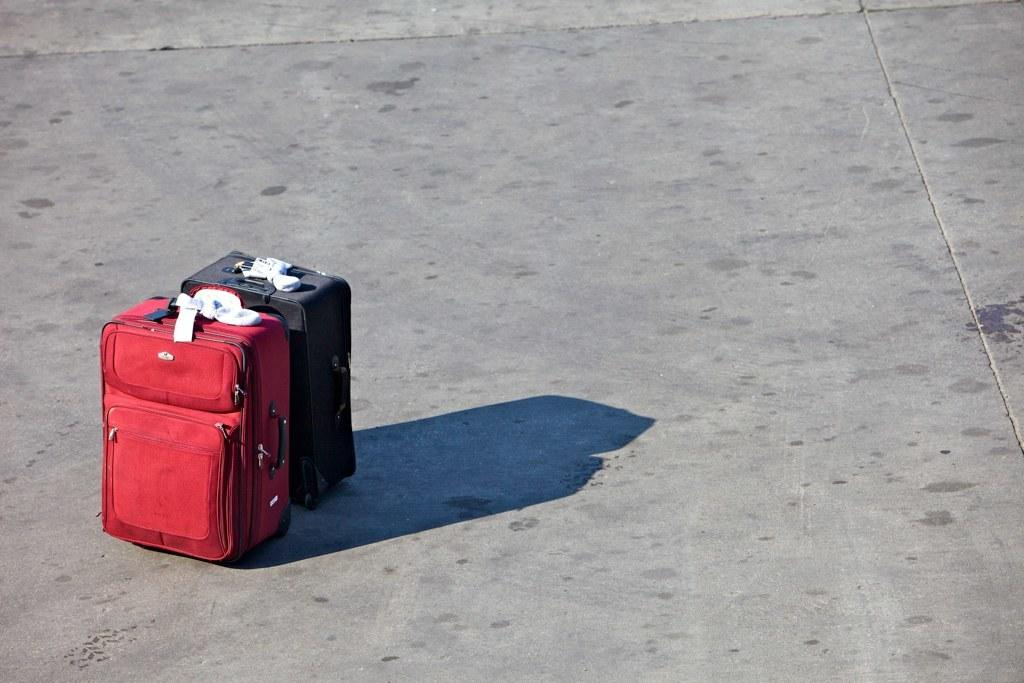How many luggage can be seen in the image? There are two luggage in the in the image. Where are the luggage placed in the image? The luggage are kept on the floor. What type of skin is visible on the luggage in the image? There is no skin visible on the luggage in the image; they are inanimate objects. 